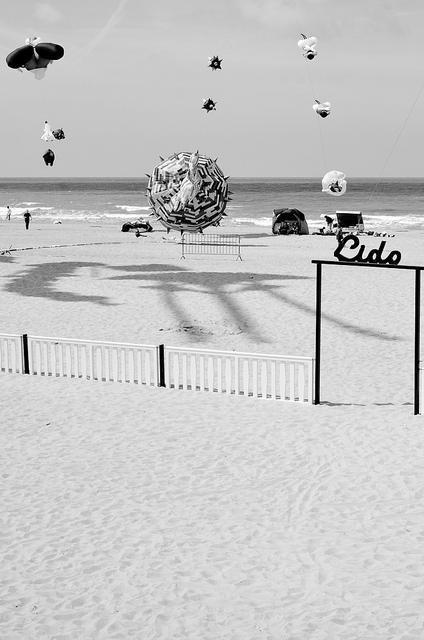How many umbrellas  are there in photo?
Give a very brief answer. 0. 